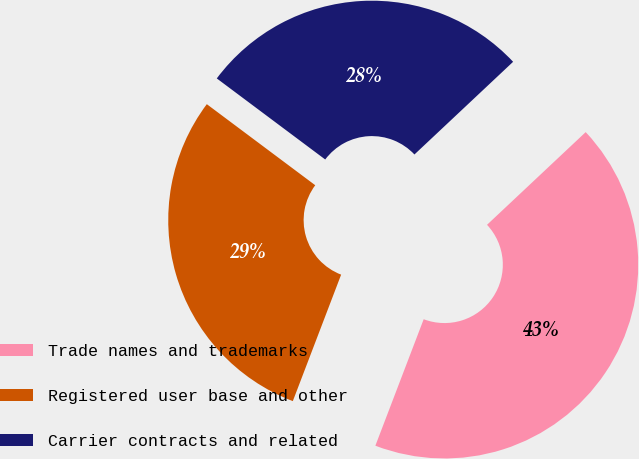Convert chart. <chart><loc_0><loc_0><loc_500><loc_500><pie_chart><fcel>Trade names and trademarks<fcel>Registered user base and other<fcel>Carrier contracts and related<nl><fcel>42.81%<fcel>29.41%<fcel>27.78%<nl></chart> 